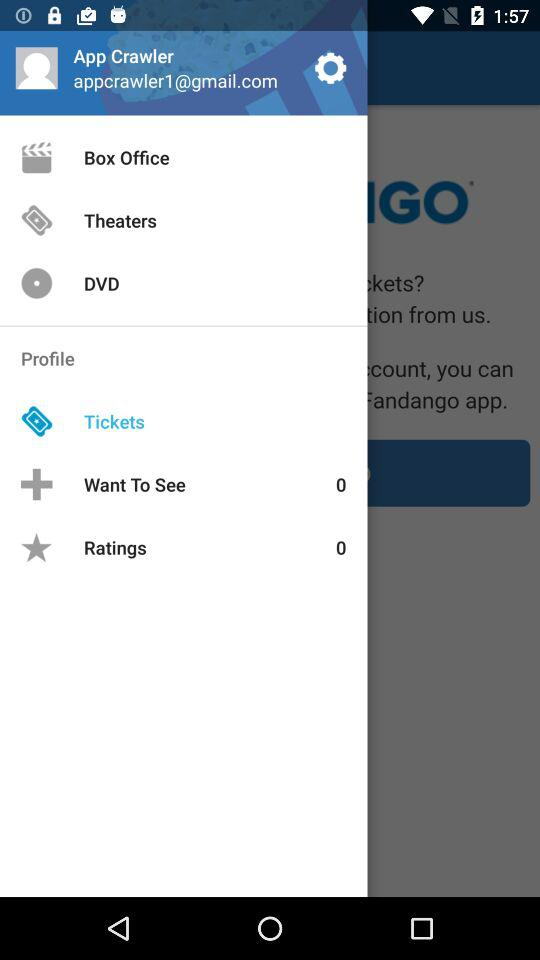What's the selected item in "Profile"? The selected item in "Profile" is "Tickets". 